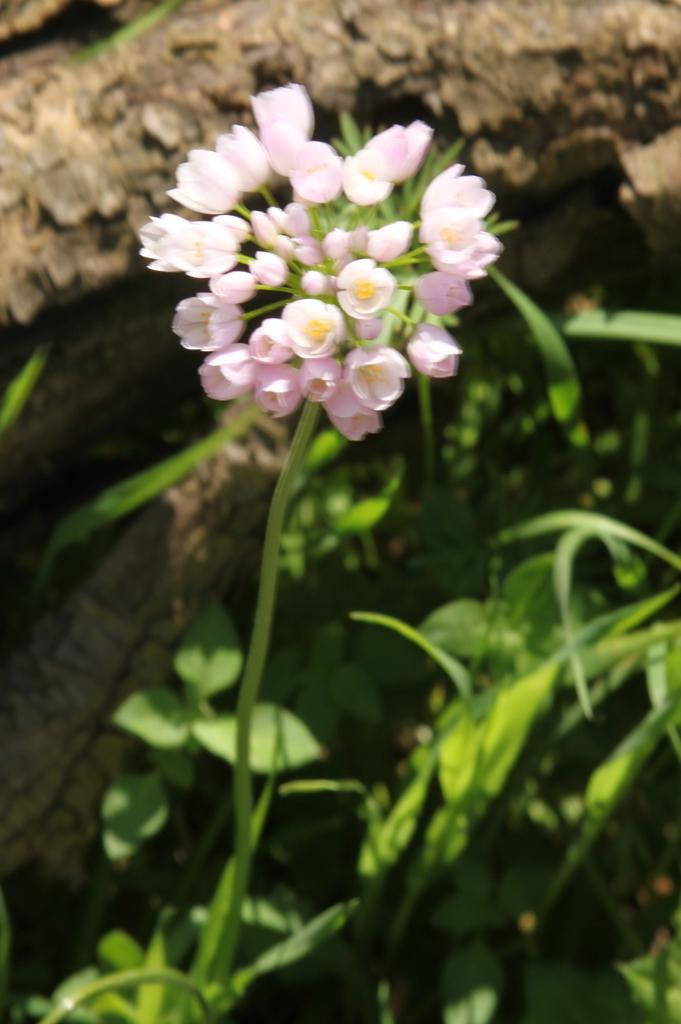What color are the flowers in the image? The flowers in the image are pink. What part of the flowers can be seen besides the petals? The flowers have stems. What can be seen in the background of the image? There is bark of a tree and leaves visible in the background of the image. What type of shirt is the person wearing in the image? There is no person present in the image, so it is not possible to determine what type of shirt they might be wearing. 